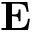<formula> <loc_0><loc_0><loc_500><loc_500>{ E }</formula> 